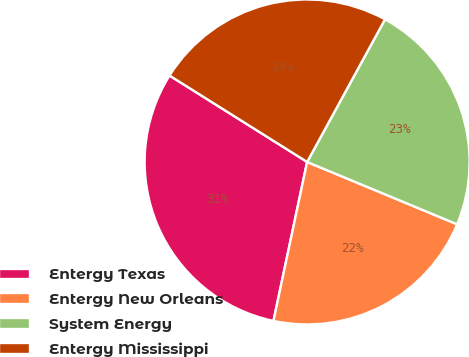Convert chart to OTSL. <chart><loc_0><loc_0><loc_500><loc_500><pie_chart><fcel>Entergy Texas<fcel>Entergy New Orleans<fcel>System Energy<fcel>Entergy Mississippi<nl><fcel>30.6%<fcel>22.05%<fcel>23.31%<fcel>24.03%<nl></chart> 